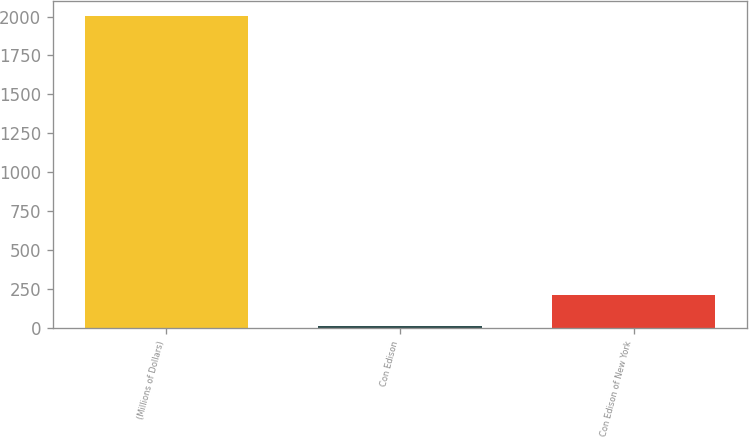Convert chart. <chart><loc_0><loc_0><loc_500><loc_500><bar_chart><fcel>(Millions of Dollars)<fcel>Con Edison<fcel>Con Edison of New York<nl><fcel>2001<fcel>14<fcel>212.7<nl></chart> 